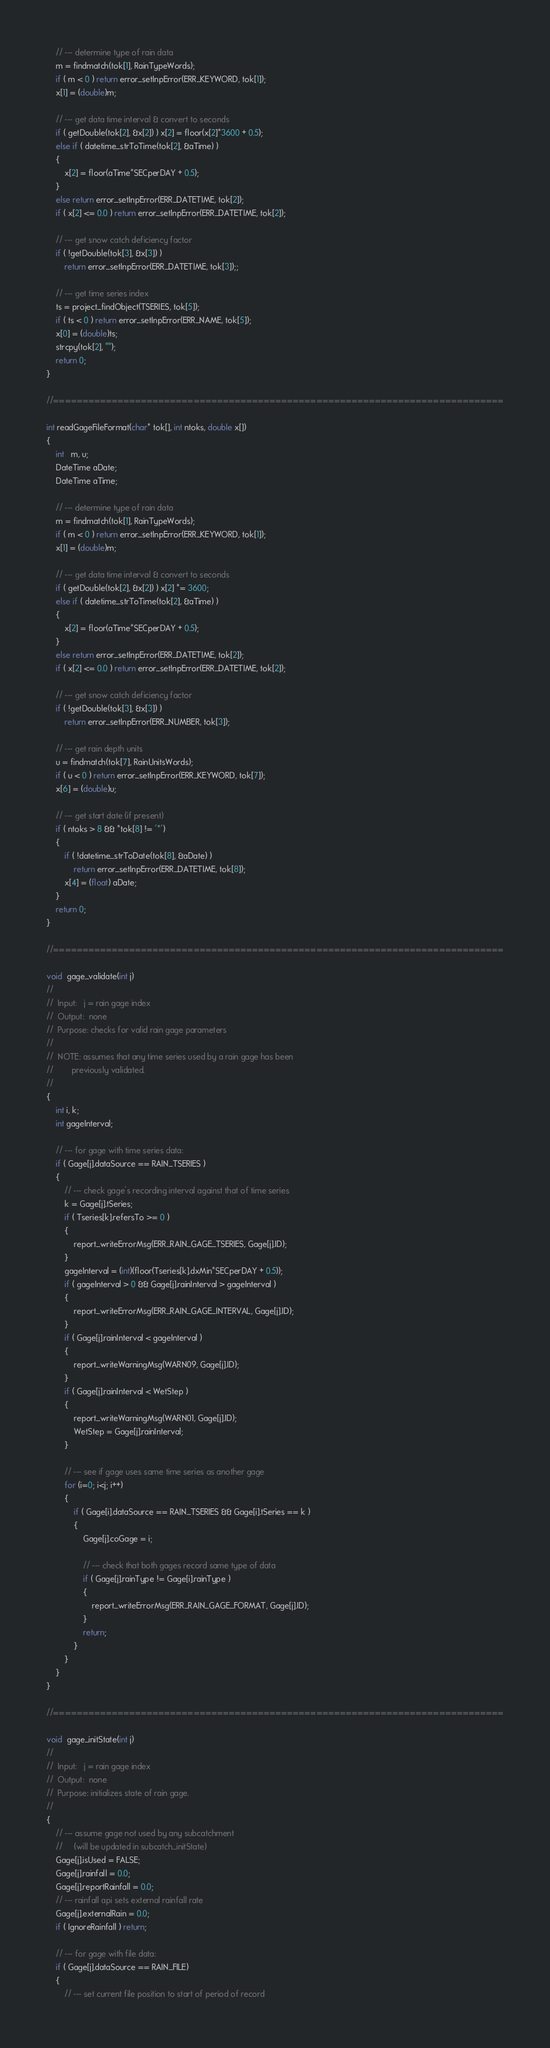<code> <loc_0><loc_0><loc_500><loc_500><_C_>
    // --- determine type of rain data
    m = findmatch(tok[1], RainTypeWords);
    if ( m < 0 ) return error_setInpError(ERR_KEYWORD, tok[1]);
    x[1] = (double)m;

    // --- get data time interval & convert to seconds
    if ( getDouble(tok[2], &x[2]) ) x[2] = floor(x[2]*3600 + 0.5);
    else if ( datetime_strToTime(tok[2], &aTime) )
    {
        x[2] = floor(aTime*SECperDAY + 0.5);
    }
    else return error_setInpError(ERR_DATETIME, tok[2]);
    if ( x[2] <= 0.0 ) return error_setInpError(ERR_DATETIME, tok[2]);

    // --- get snow catch deficiency factor
    if ( !getDouble(tok[3], &x[3]) )
        return error_setInpError(ERR_DATETIME, tok[3]);;

    // --- get time series index
    ts = project_findObject(TSERIES, tok[5]);
    if ( ts < 0 ) return error_setInpError(ERR_NAME, tok[5]);
    x[0] = (double)ts;
    strcpy(tok[2], "");
    return 0;
}

//=============================================================================

int readGageFileFormat(char* tok[], int ntoks, double x[])
{
    int   m, u;
    DateTime aDate;
    DateTime aTime;

    // --- determine type of rain data
    m = findmatch(tok[1], RainTypeWords);
    if ( m < 0 ) return error_setInpError(ERR_KEYWORD, tok[1]);
    x[1] = (double)m;

    // --- get data time interval & convert to seconds
    if ( getDouble(tok[2], &x[2]) ) x[2] *= 3600;
    else if ( datetime_strToTime(tok[2], &aTime) )
    {
        x[2] = floor(aTime*SECperDAY + 0.5);
    }
    else return error_setInpError(ERR_DATETIME, tok[2]);
    if ( x[2] <= 0.0 ) return error_setInpError(ERR_DATETIME, tok[2]);

    // --- get snow catch deficiency factor
    if ( !getDouble(tok[3], &x[3]) )
        return error_setInpError(ERR_NUMBER, tok[3]);
 
    // --- get rain depth units
    u = findmatch(tok[7], RainUnitsWords);
    if ( u < 0 ) return error_setInpError(ERR_KEYWORD, tok[7]);
    x[6] = (double)u;

    // --- get start date (if present)
    if ( ntoks > 8 && *tok[8] != '*')
    {
        if ( !datetime_strToDate(tok[8], &aDate) )
            return error_setInpError(ERR_DATETIME, tok[8]);
        x[4] = (float) aDate;
    }
    return 0;
}

//=============================================================================

void  gage_validate(int j)
//
//  Input:   j = rain gage index
//  Output:  none
//  Purpose: checks for valid rain gage parameters
//
//  NOTE: assumes that any time series used by a rain gage has been
//        previously validated.
//
{
    int i, k;
    int gageInterval;

    // --- for gage with time series data:
    if ( Gage[j].dataSource == RAIN_TSERIES )
    {
        // --- check gage's recording interval against that of time series
        k = Gage[j].tSeries;
        if ( Tseries[k].refersTo >= 0 )
        {
            report_writeErrorMsg(ERR_RAIN_GAGE_TSERIES, Gage[j].ID);
        }
        gageInterval = (int)(floor(Tseries[k].dxMin*SECperDAY + 0.5));
        if ( gageInterval > 0 && Gage[j].rainInterval > gageInterval )
        {
            report_writeErrorMsg(ERR_RAIN_GAGE_INTERVAL, Gage[j].ID);
        } 
        if ( Gage[j].rainInterval < gageInterval )
        {
            report_writeWarningMsg(WARN09, Gage[j].ID);
        }
        if ( Gage[j].rainInterval < WetStep )
        {
            report_writeWarningMsg(WARN01, Gage[j].ID);
            WetStep = Gage[j].rainInterval;
        }

        // --- see if gage uses same time series as another gage
        for (i=0; i<j; i++)
        {
            if ( Gage[i].dataSource == RAIN_TSERIES && Gage[i].tSeries == k )
            {
                Gage[j].coGage = i;

                // --- check that both gages record same type of data
                if ( Gage[j].rainType != Gage[i].rainType )
                {
                    report_writeErrorMsg(ERR_RAIN_GAGE_FORMAT, Gage[j].ID);
                }
                return;
            }
        }
    }
}

//=============================================================================

void  gage_initState(int j)
//
//  Input:   j = rain gage index
//  Output:  none
//  Purpose: initializes state of rain gage.
//
{
    // --- assume gage not used by any subcatchment
    //     (will be updated in subcatch_initState)
    Gage[j].isUsed = FALSE;
    Gage[j].rainfall = 0.0;
    Gage[j].reportRainfall = 0.0;
    // --- rainfall api sets external rainfall rate
    Gage[j].externalRain = 0.0;
    if ( IgnoreRainfall ) return;

    // --- for gage with file data:
    if ( Gage[j].dataSource == RAIN_FILE)
    {
        // --- set current file position to start of period of record</code> 